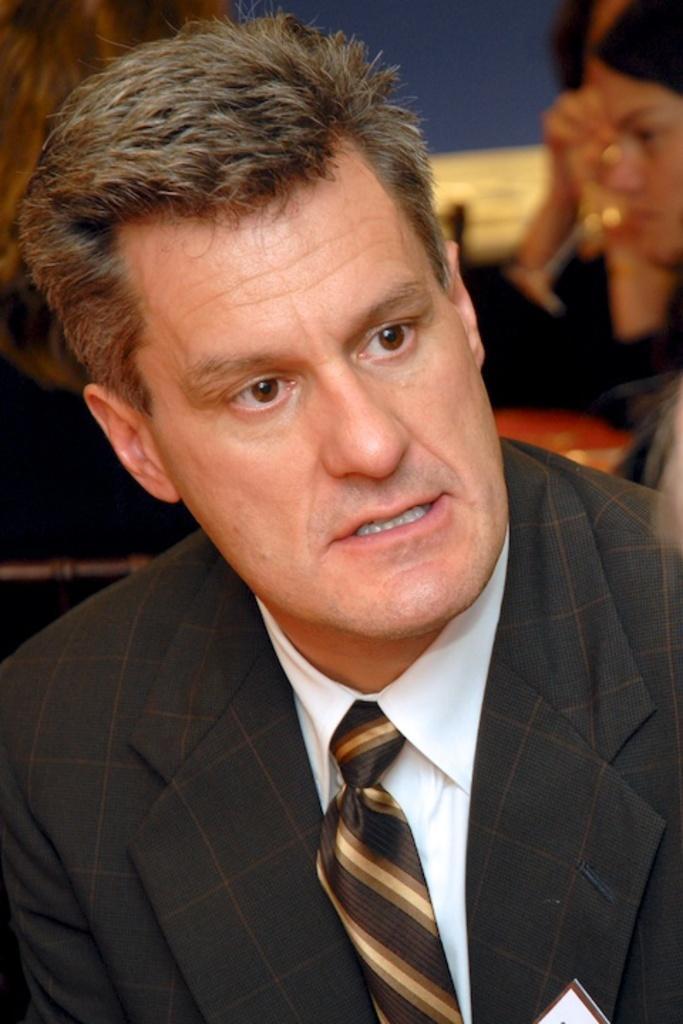Describe this image in one or two sentences. This image consists of a man wearing a black suit and a tie. In the background, there are many people. He is also wearing a white shirt. 